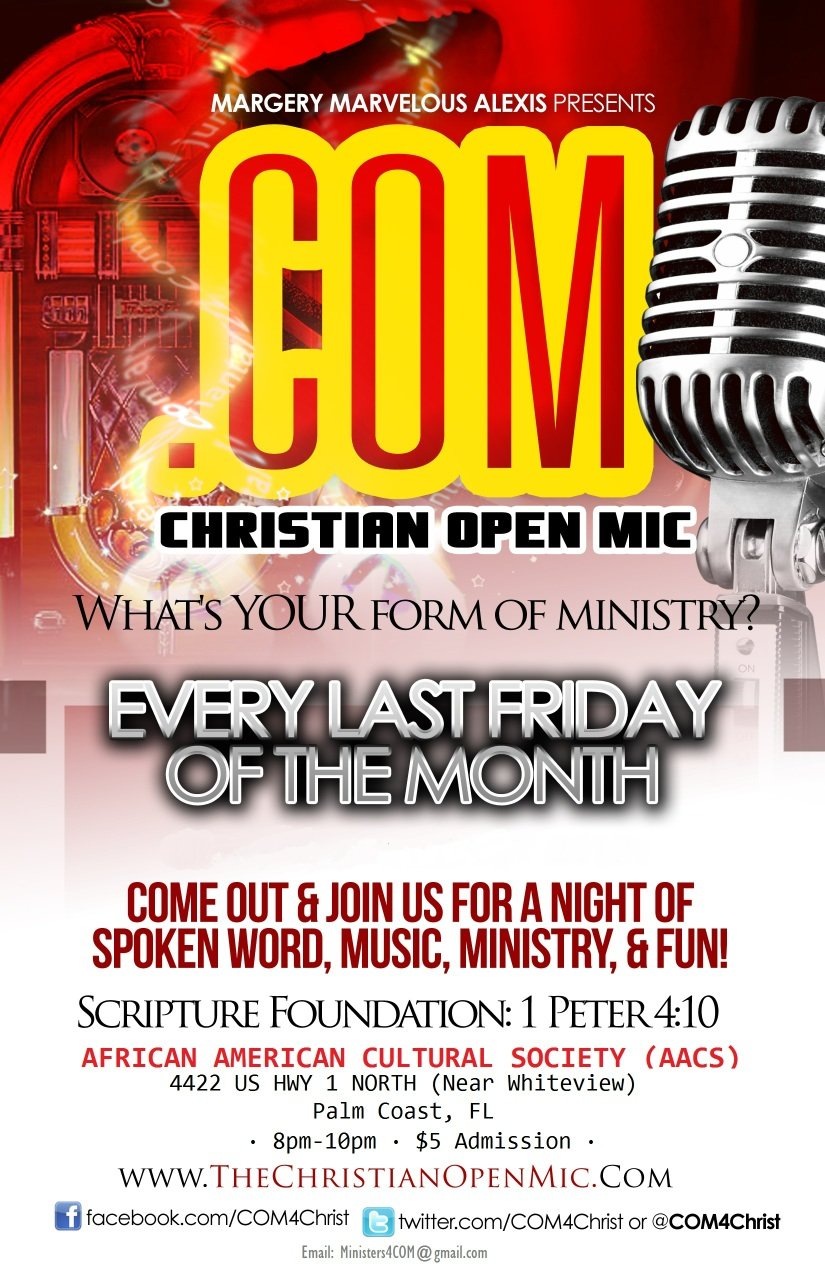If you could imagine the African American Cultural Society hosting a grand festival, what would it look like? Imagine the African American Cultural Society hosting a grand festival called 'Celebration of Heritage'. The event would extend over an entire weekend, starting with a spectacular opening ceremony featuring a parade showcasing vibrant cultural costumes, traditional music, and dance performances. Various stalls and booths would be set up around the venue, offering a wide range of traditional foods, crafts, and artwork. Interactive workshops would be held where attendees could learn about African American history, dance, storytelling, and crafts. There would be stages set up for live performances, featuring choirs, spoken word artists, and keynote speakers sharing powerful messages of unity, progress, and cultural pride. Children's activities would include face painting, storytelling sessions, and art contests. The festival would culminate in a grand concert, bringing together renowned artists and local talents for an evening of unforgettable music and celebration. This event would not only celebrate the rich cultural heritage of African Americans but also foster a sense of community and togetherness. 